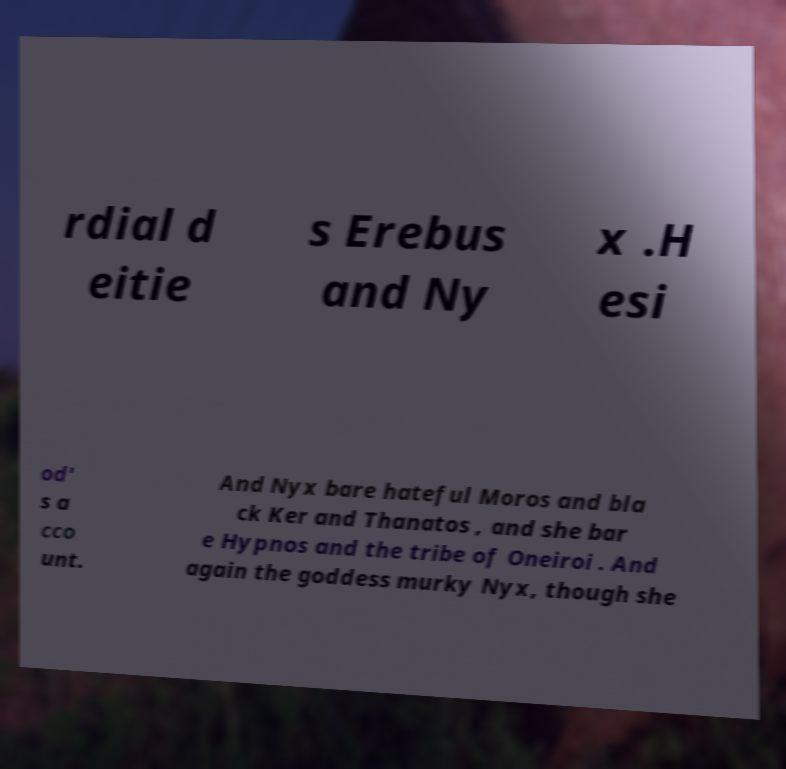Please identify and transcribe the text found in this image. rdial d eitie s Erebus and Ny x .H esi od' s a cco unt. And Nyx bare hateful Moros and bla ck Ker and Thanatos , and she bar e Hypnos and the tribe of Oneiroi . And again the goddess murky Nyx, though she 